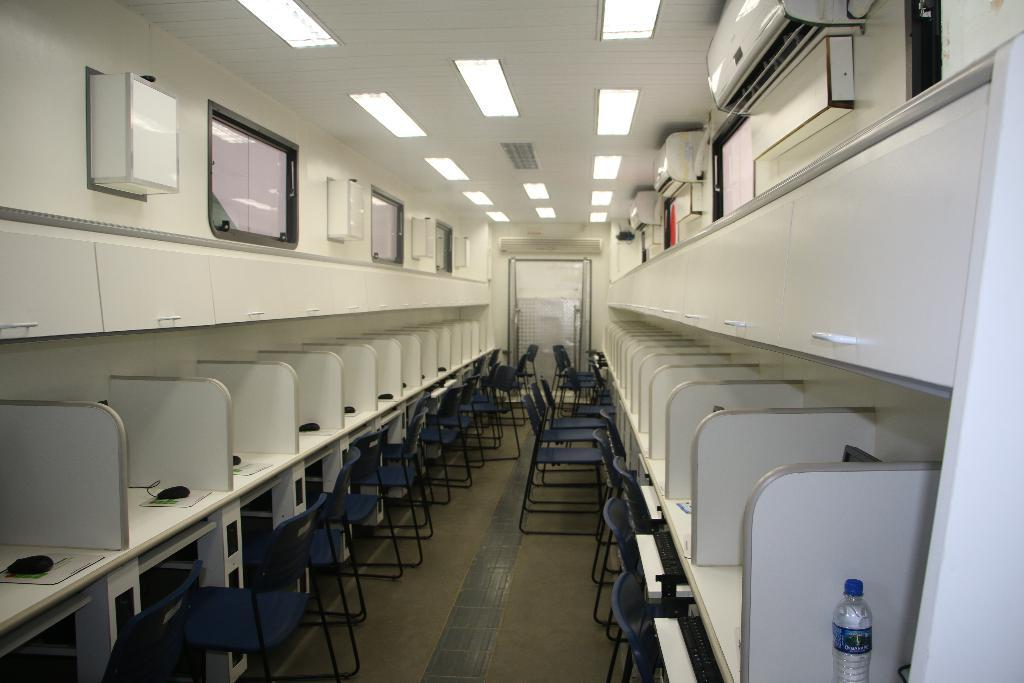What type of room is shown in the image? The image depicts a computer lab. What furniture is present in the computer lab? There are computer desks and chairs in the image. How are the chairs arranged in relation to the computer desks? The chairs are in front of the computer desks. What month is depicted in the image? The image does not depict a month; it shows a computer lab with computer desks and chairs. How many pens are visible on the computer desks? There are no pens visible on the computer desks in the image. 